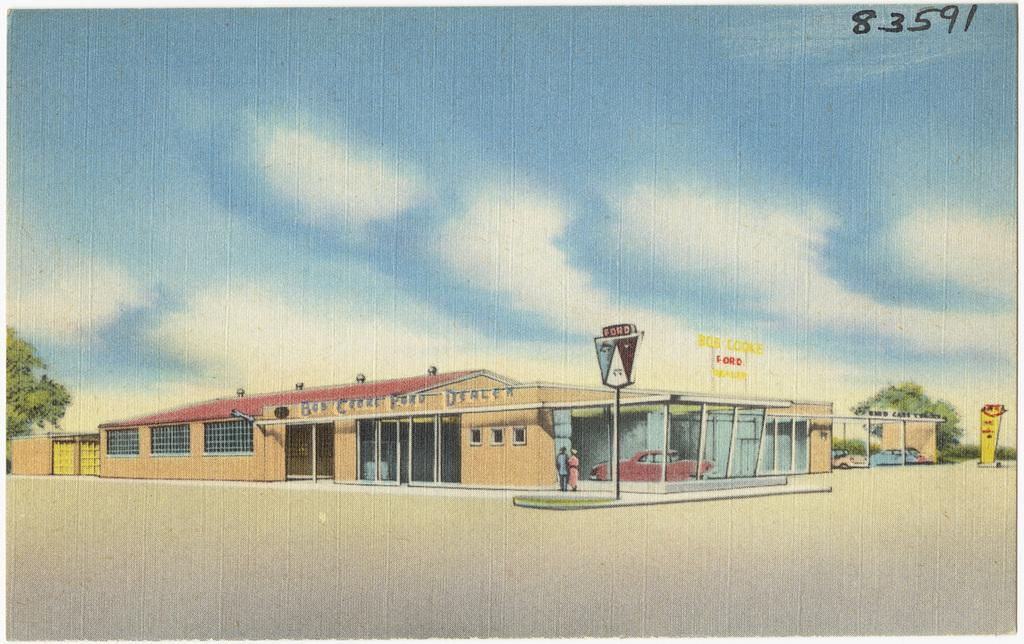<image>
Create a compact narrative representing the image presented. A sketch of a small building indicates that it is a Ford dealership. 